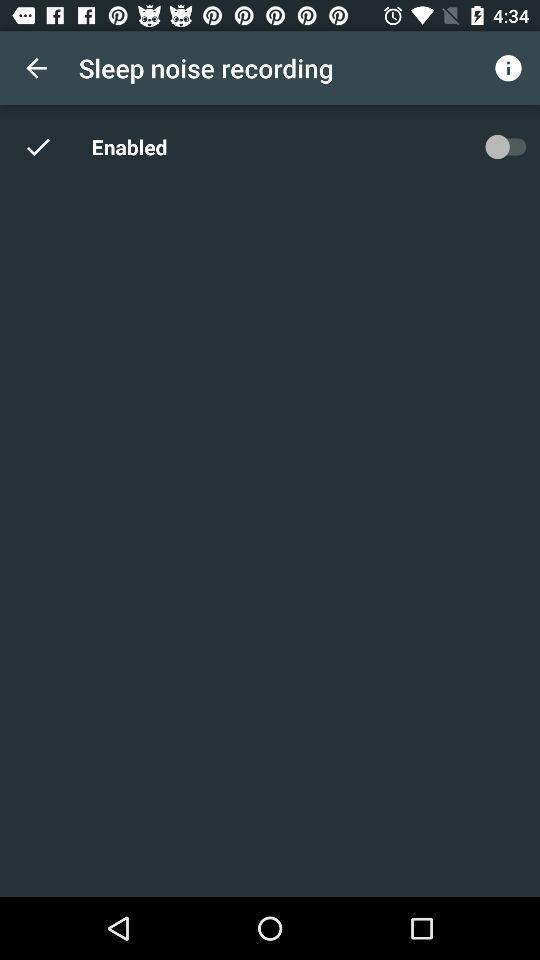What is the status of the "Enabled" setting? The status is "off". 